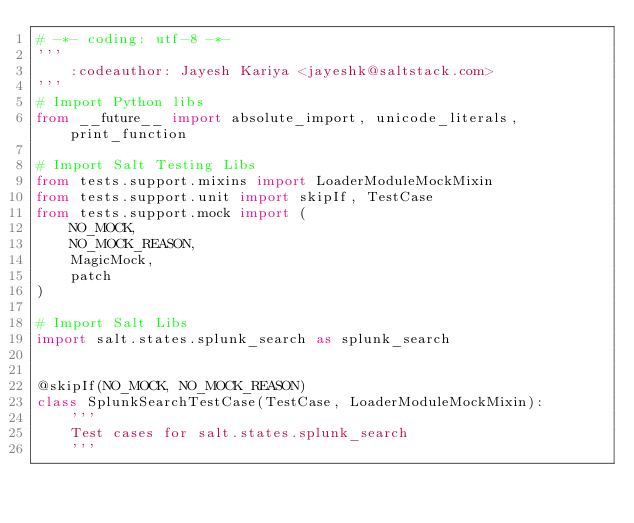Convert code to text. <code><loc_0><loc_0><loc_500><loc_500><_Python_># -*- coding: utf-8 -*-
'''
    :codeauthor: Jayesh Kariya <jayeshk@saltstack.com>
'''
# Import Python libs
from __future__ import absolute_import, unicode_literals, print_function

# Import Salt Testing Libs
from tests.support.mixins import LoaderModuleMockMixin
from tests.support.unit import skipIf, TestCase
from tests.support.mock import (
    NO_MOCK,
    NO_MOCK_REASON,
    MagicMock,
    patch
)

# Import Salt Libs
import salt.states.splunk_search as splunk_search


@skipIf(NO_MOCK, NO_MOCK_REASON)
class SplunkSearchTestCase(TestCase, LoaderModuleMockMixin):
    '''
    Test cases for salt.states.splunk_search
    '''</code> 